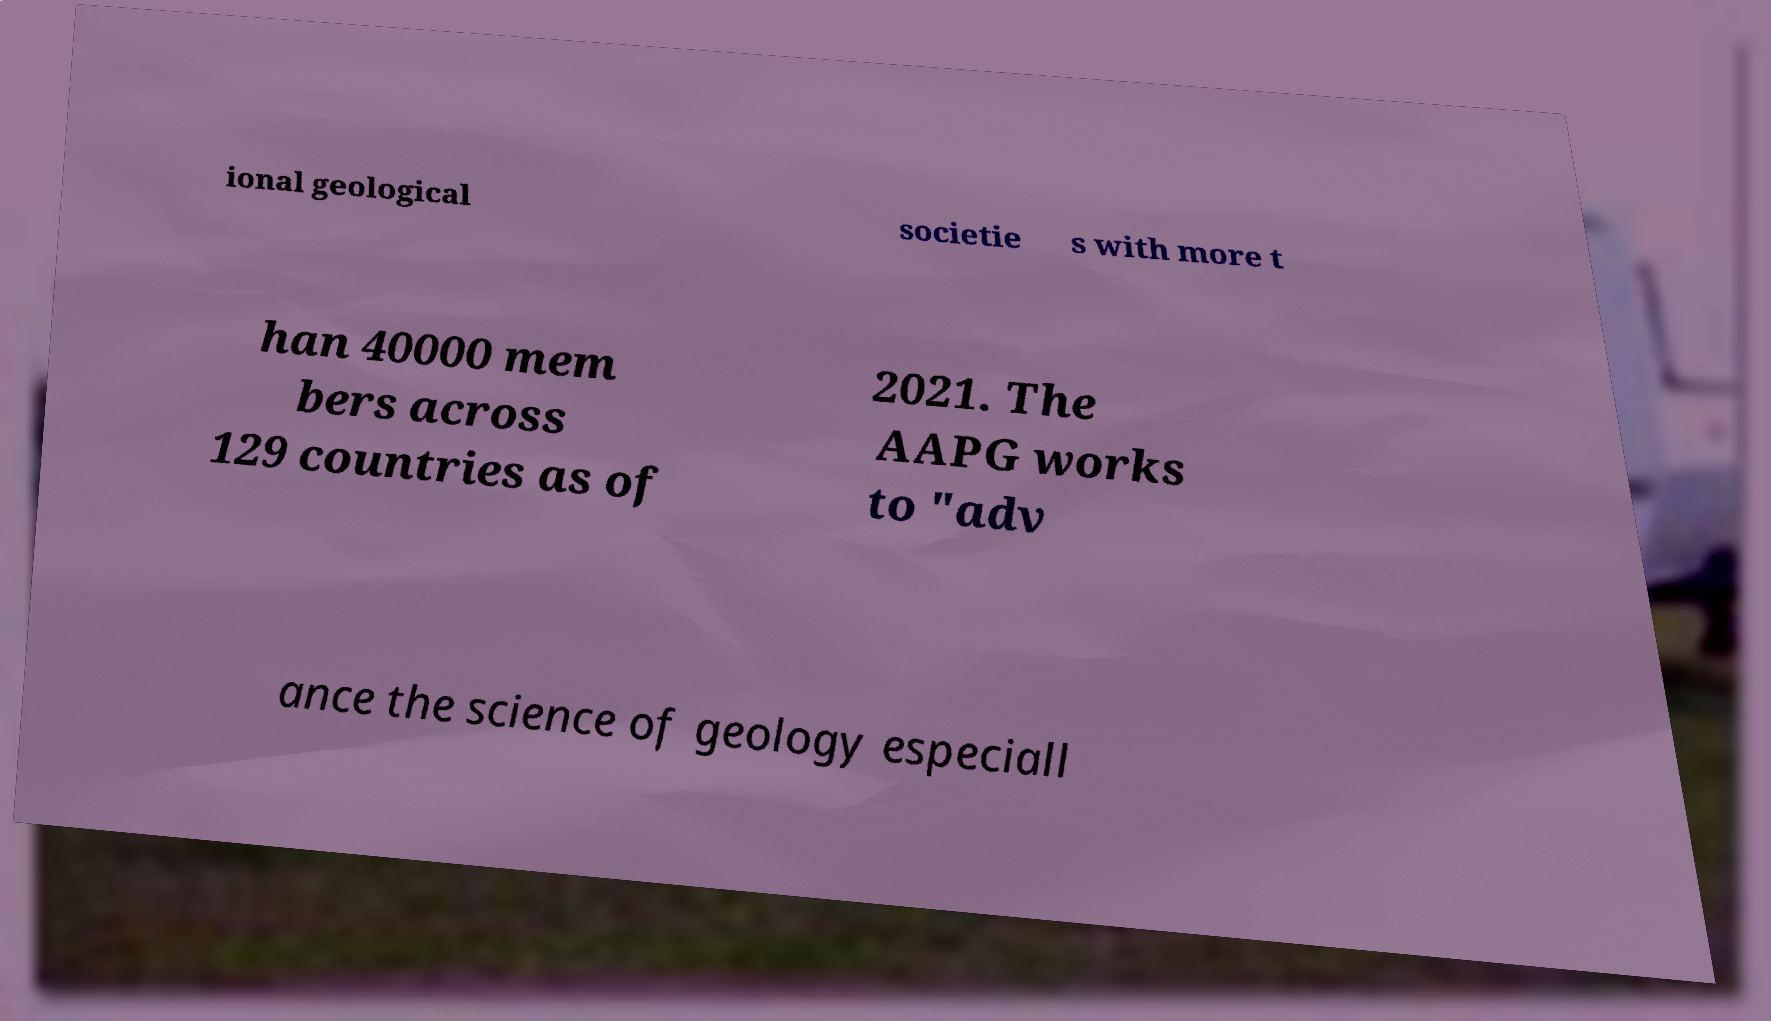Please identify and transcribe the text found in this image. ional geological societie s with more t han 40000 mem bers across 129 countries as of 2021. The AAPG works to "adv ance the science of geology especiall 